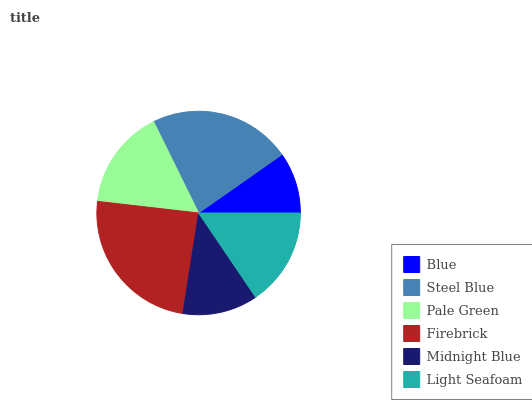Is Blue the minimum?
Answer yes or no. Yes. Is Firebrick the maximum?
Answer yes or no. Yes. Is Steel Blue the minimum?
Answer yes or no. No. Is Steel Blue the maximum?
Answer yes or no. No. Is Steel Blue greater than Blue?
Answer yes or no. Yes. Is Blue less than Steel Blue?
Answer yes or no. Yes. Is Blue greater than Steel Blue?
Answer yes or no. No. Is Steel Blue less than Blue?
Answer yes or no. No. Is Pale Green the high median?
Answer yes or no. Yes. Is Light Seafoam the low median?
Answer yes or no. Yes. Is Blue the high median?
Answer yes or no. No. Is Steel Blue the low median?
Answer yes or no. No. 